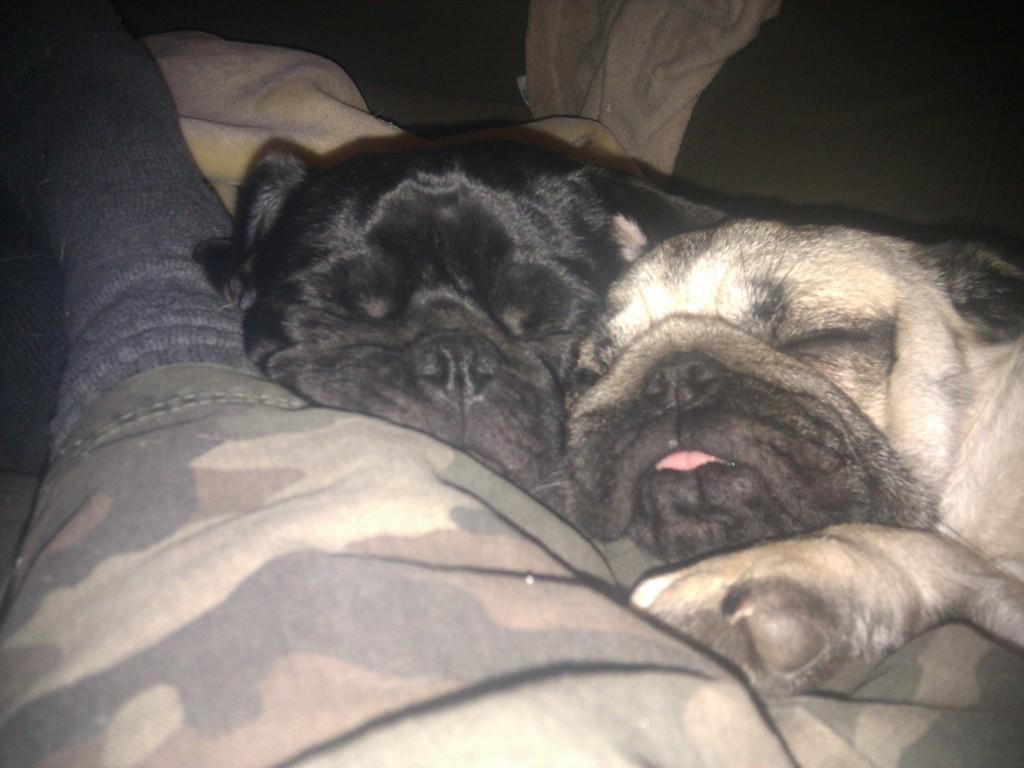Can you describe this image briefly? In this image there is a dog taking a nap. 